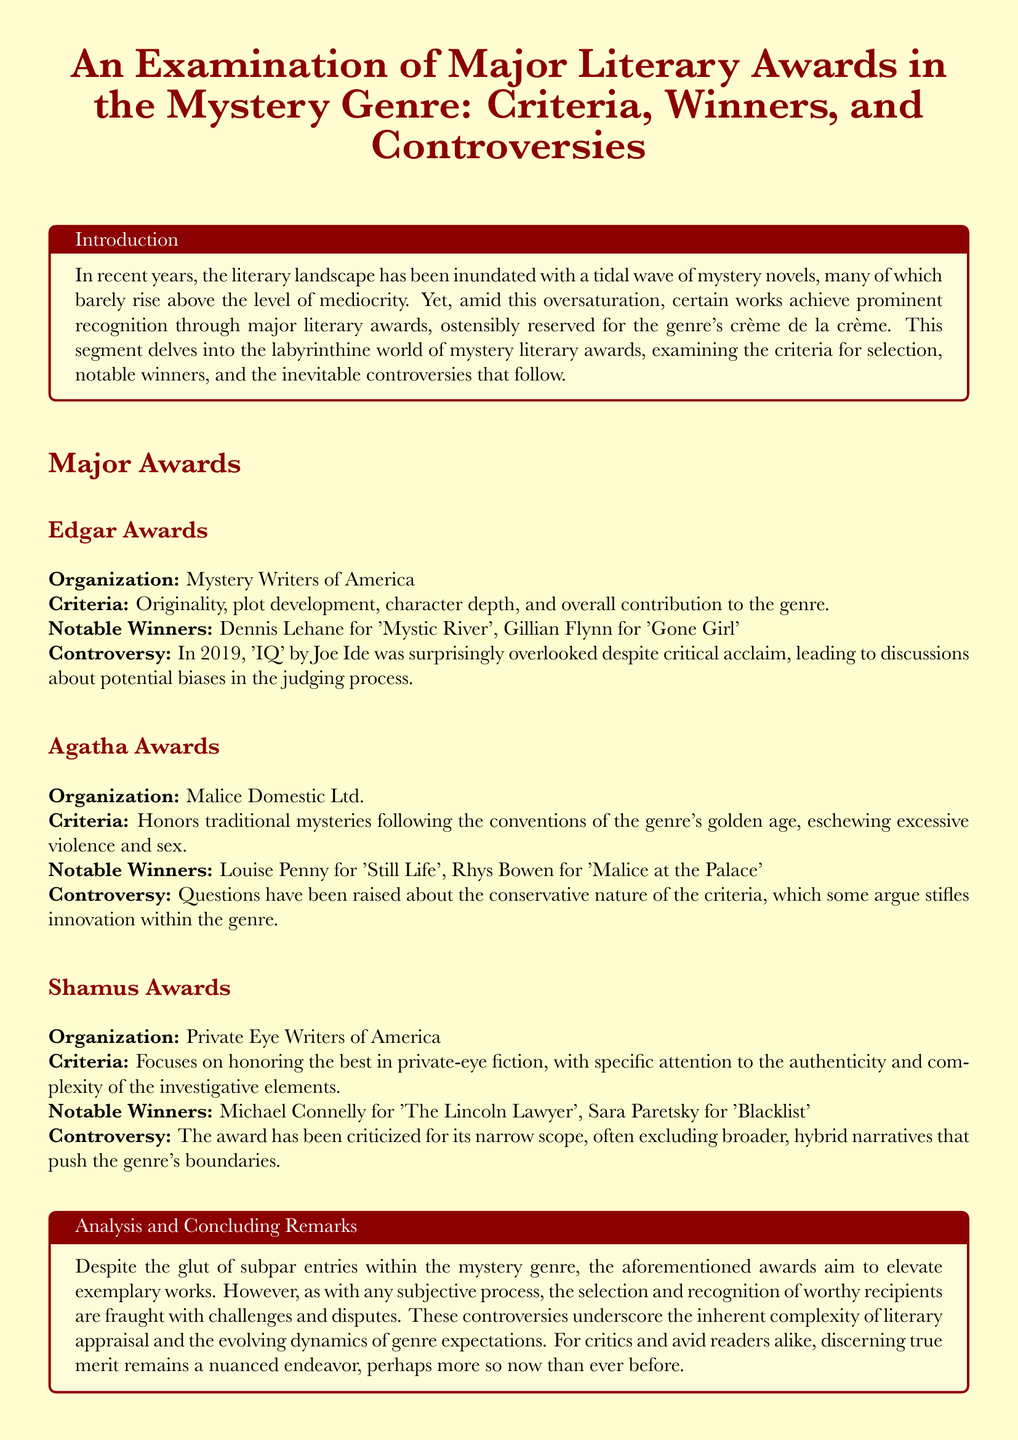what organization presents the Edgar Awards? The Edgar Awards are presented by the Mystery Writers of America.
Answer: Mystery Writers of America who won the Edgar Award for 'Gone Girl'? Gillian Flynn won the Edgar Award for 'Gone Girl'.
Answer: Gillian Flynn what is the primary criterion for the Agatha Awards? The Agatha Awards honor traditional mysteries following the conventions of the genre's golden age.
Answer: traditional mysteries which award has been criticized for its narrow scope? The Shamus Awards have been criticized for its narrow scope.
Answer: Shamus Awards what notable winner is associated with the Shamus Awards? Michael Connelly won the Shamus Awards for 'The Lincoln Lawyer'.
Answer: Michael Connelly what year did the controversy regarding 'IQ' by Joe Ide occur? The controversy regarding 'IQ' by Joe Ide occurred in 2019.
Answer: 2019 what is a common issue discussed in the document regarding literary awards? The document discusses the inherent complexity of literary appraisal and the evolving dynamics of genre expectations.
Answer: controversies what is one criticism of the Agatha Awards criteria? Questions have been raised about the conservative nature of the criteria.
Answer: conservative nature 